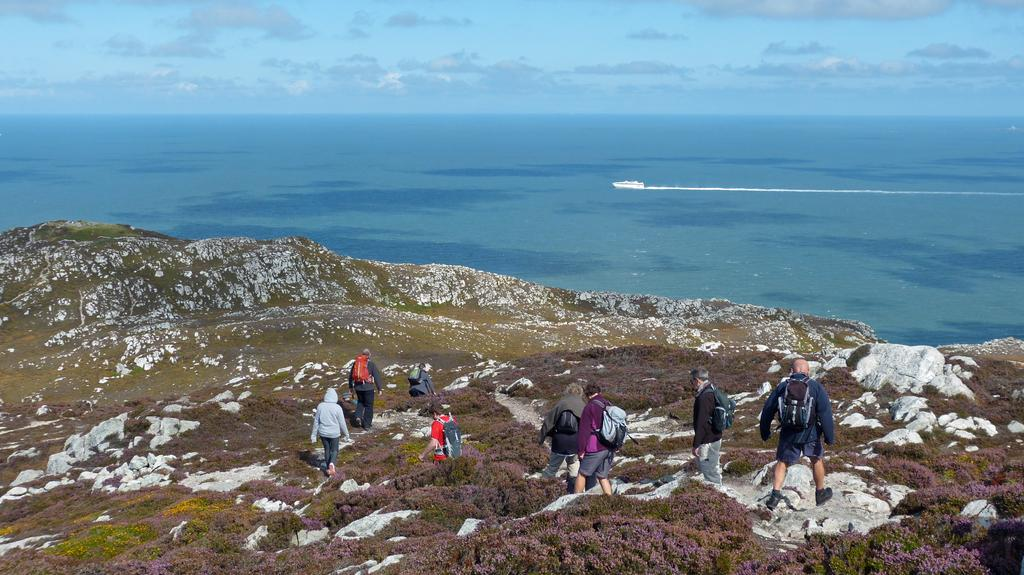What are the people in the image doing? The people in the image are walking on a hill. What can be seen in the water in the image? There is a ship visible on the water in the image. What type of apple is being used to paint the bottle in the image? There is no apple or bottle present in the image; it features people walking on a hill and a ship on the water. 